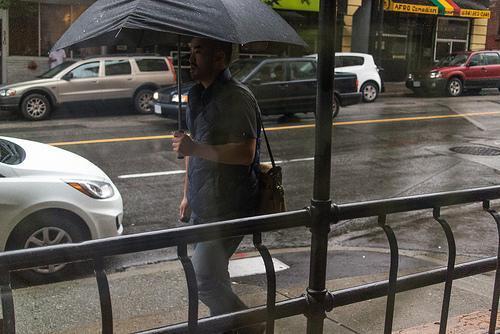How many cars can you see?
Give a very brief answer. 5. How many lions are in the picture?
Give a very brief answer. 0. 